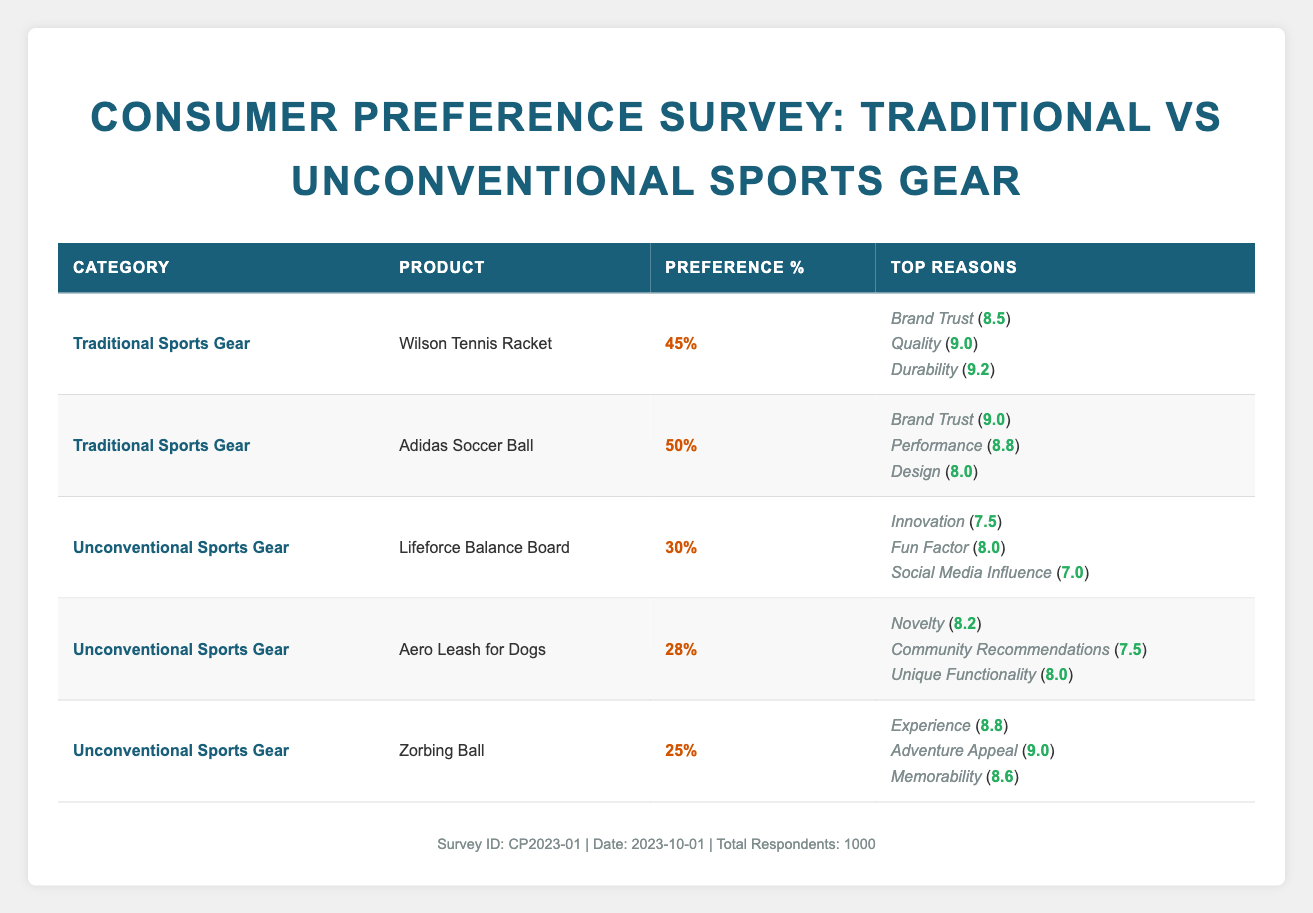What is the highest preference percentage and which product does it belong to? The table contains preference percentages for each product. The highest preference percentage is 50%, which belongs to the Adidas Soccer Ball.
Answer: 50%, Adidas Soccer Ball Which traditional sports gear has the lowest preference percentage? The Wilson Tennis Racket has a preference percentage of 45%, while the Adidas Soccer Ball has a higher percentage of 50%. Therefore, the Wilson Tennis Racket has the lowest preference percentage among traditional sports gear.
Answer: 45%, Wilson Tennis Racket What is the average preference percentage for unconventional sports gear? The preference percentages for unconventional sports gear are 30%, 28%, and 25%. To find the average, sum them up: 30 + 28 + 25 = 83, and divide by the number of products (3): 83 / 3 ≈ 27.67.
Answer: Approximately 27.67 Is there a significant gap between preference scores for traditional and unconventional gear? The highest preference percentage for traditional sports gear is 50% (Adidas Soccer Ball), while the highest for unconventional gear is 30% (Lifeforce Balance Board). The difference is 50% - 30% = 20%. This indicates a significant gap between the two categories.
Answer: Yes Which factor for traditional sports gear scored the highest for the Adidas Soccer Ball and what was its score? The Adidas Soccer Ball's factors are Brand Trust (9.0), Performance (8.8), and Design (8.0). The highest score among these factors is for Brand Trust, which scored 9.0.
Answer: Brand Trust, 9.0 What is the total preference percentage of all traditional sports gear? The traditional sports gear preference percentages are 45% for the Wilson Tennis Racket and 50% for the Adidas Soccer Ball. To find the total, add these two percentages: 45 + 50 = 95.
Answer: 95% How does the novelty factor for the Aero Leash for Dogs compare with the fun factor for the Lifeforce Balance Board? The Aero Leash for Dogs has a novelty factor score of 8.2, while Lifeforce Balance Board's fun factor scores 8.0. Comparing these scores: 8.2 > 8.0, indicating that the Aero Leash for Dogs scores higher on novelty than the Lifeforce Balance Board on fun.
Answer: Novelty is higher at 8.2 What are the top three reasons for the Adidas Soccer Ball's preference score? The reasons listed for the Adidas Soccer Ball's preference are Brand Trust (9.0), Performance (8.8), and Design (8.0). These are the top three reasons contributing to its preference score.
Answer: Brand Trust, Performance, Design Which unconventional sports gear had the highest score for adventure appeal? The Zorbing Ball had the highest score for adventure appeal at 9.0 among all the unconventional sports gear listed in the table.
Answer: Zorbing Ball, 9.0 